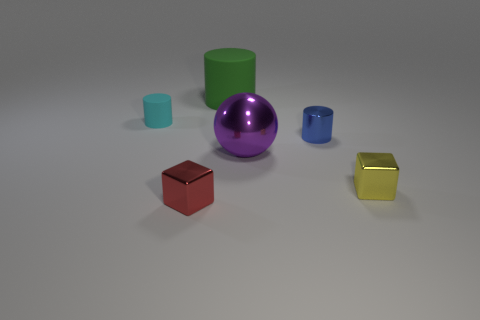Is there a pattern in the arrangement of the objects? There doesn't appear to be a specific pattern to the arrangement of the objects; they are placed seemingly at random across a flat surface. Could the arrangement be based on size or color? While there's no clear pattern, the objects do vary in size from small to large. Color-wise, they present a diverse palette with no apparent theme or gradient. 